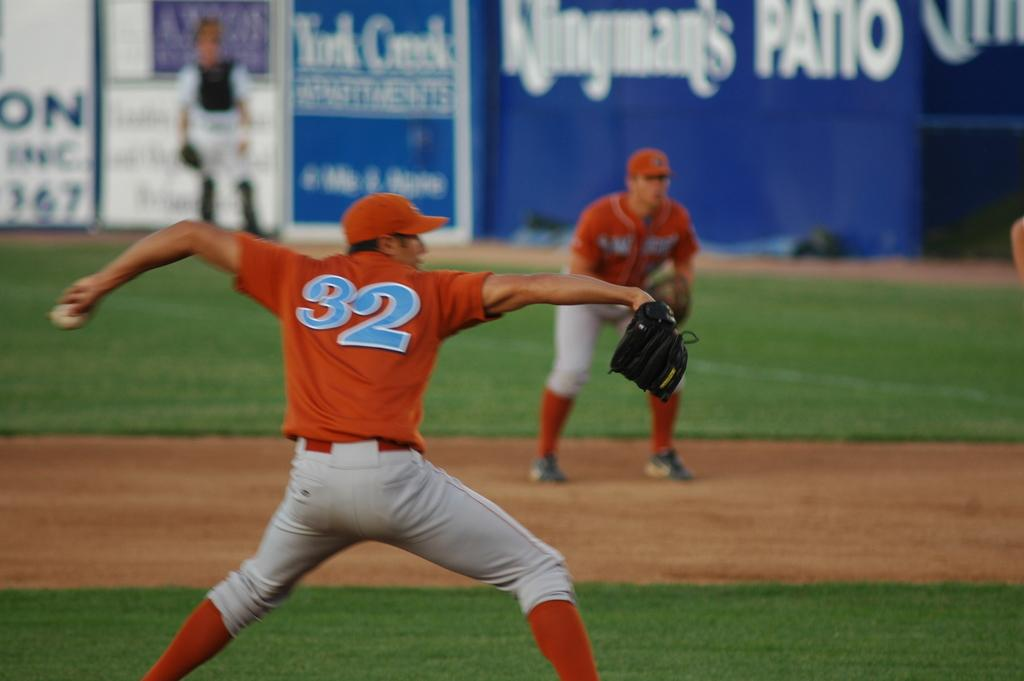<image>
Present a compact description of the photo's key features. Baseball players in front of a wall that has Klingman's Patio in white letters. 